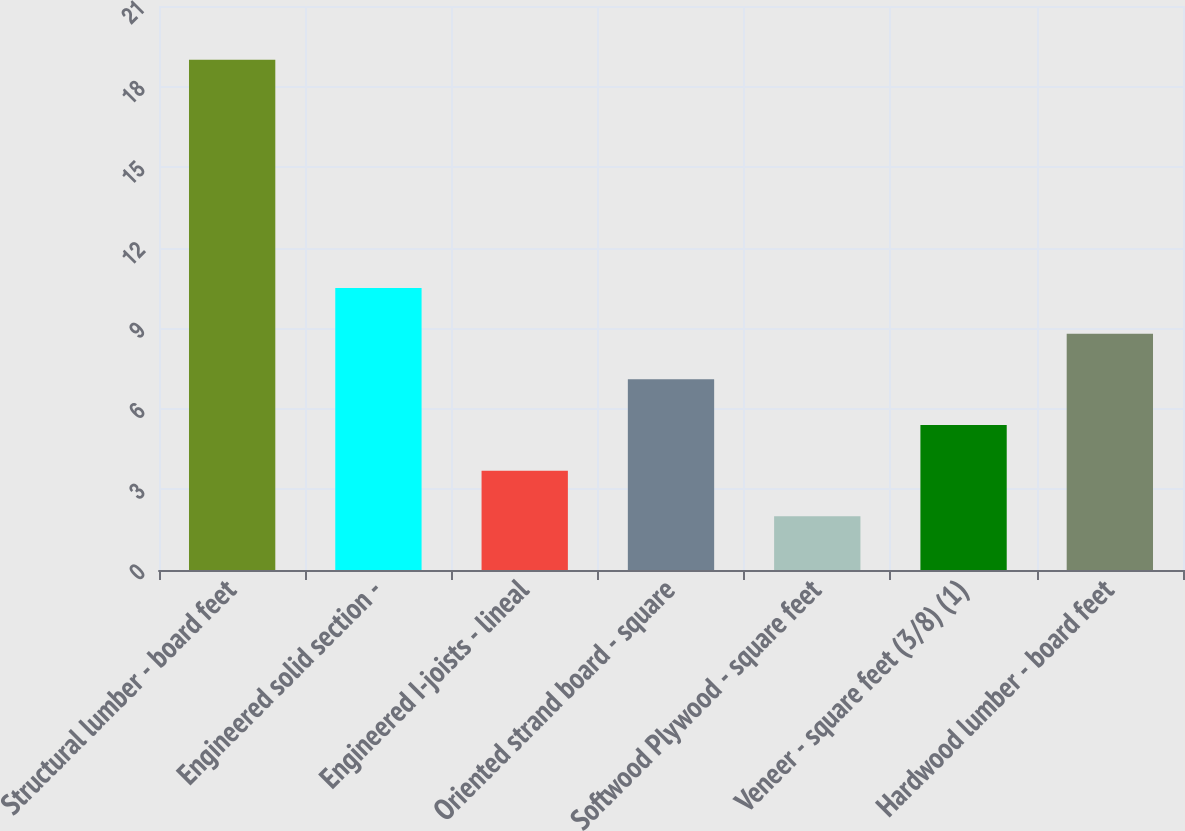<chart> <loc_0><loc_0><loc_500><loc_500><bar_chart><fcel>Structural lumber - board feet<fcel>Engineered solid section -<fcel>Engineered I-joists - lineal<fcel>Oriented strand board - square<fcel>Softwood Plywood - square feet<fcel>Veneer - square feet (3/8) (1)<fcel>Hardwood lumber - board feet<nl><fcel>19<fcel>10.5<fcel>3.7<fcel>7.1<fcel>2<fcel>5.4<fcel>8.8<nl></chart> 